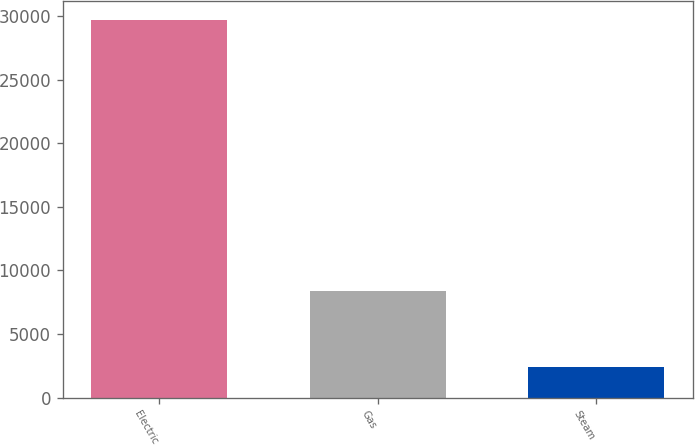Convert chart to OTSL. <chart><loc_0><loc_0><loc_500><loc_500><bar_chart><fcel>Electric<fcel>Gas<fcel>Steam<nl><fcel>29661<fcel>8387<fcel>2403<nl></chart> 